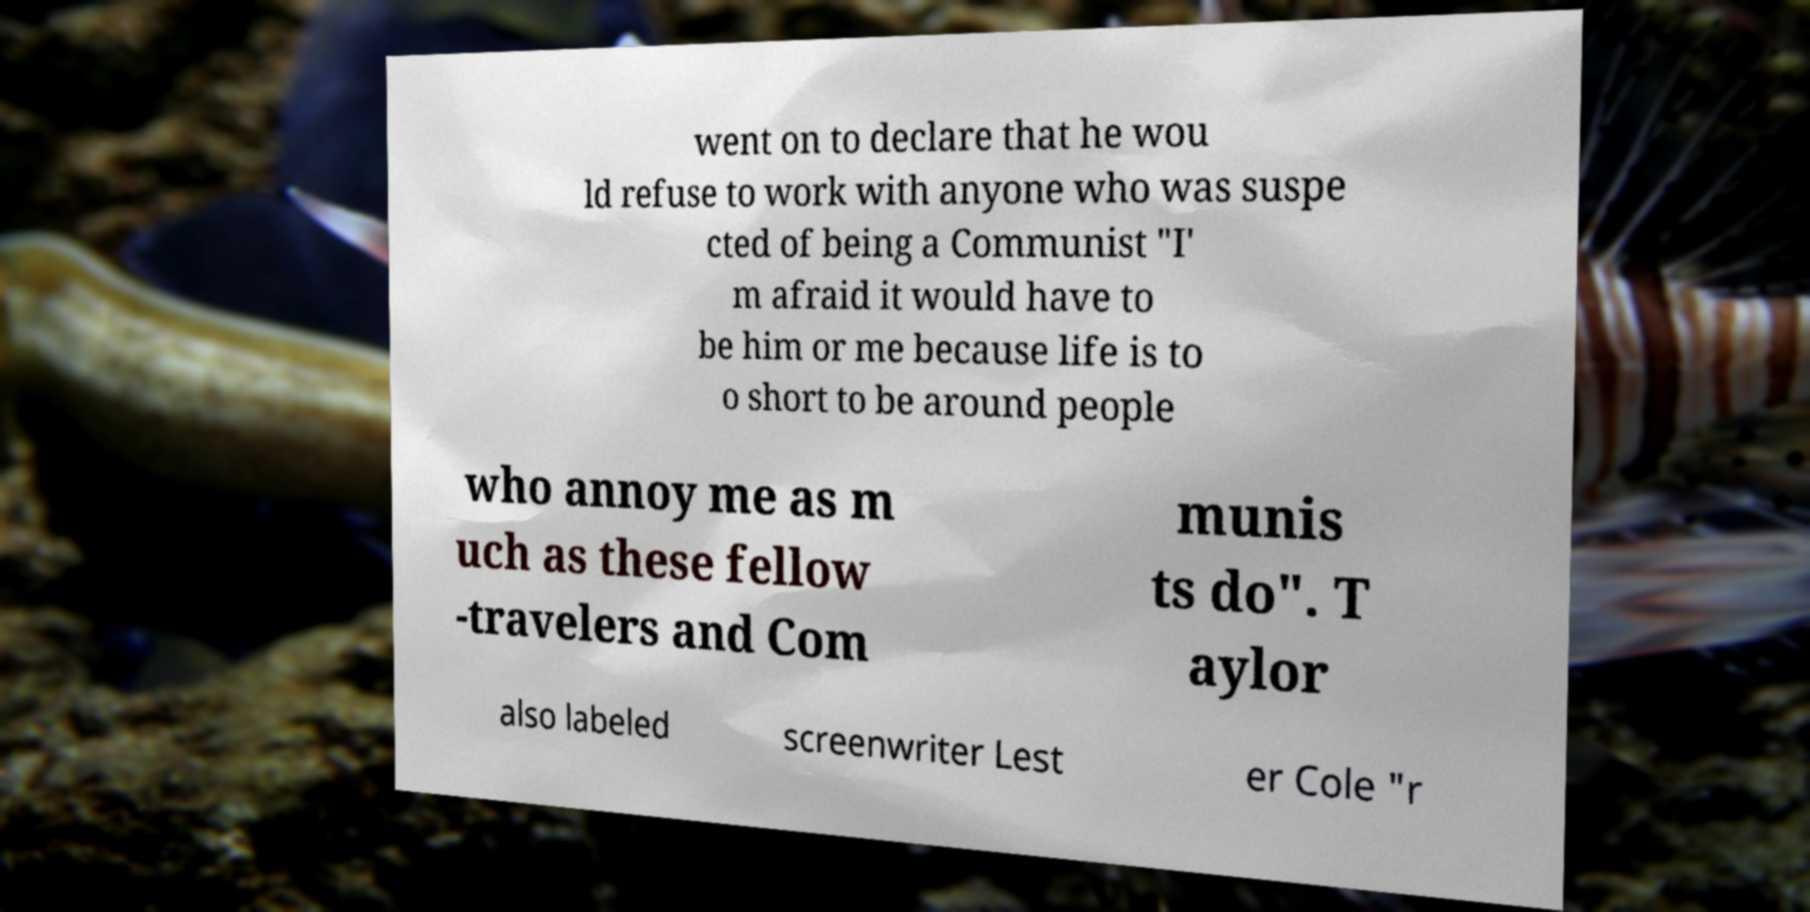There's text embedded in this image that I need extracted. Can you transcribe it verbatim? went on to declare that he wou ld refuse to work with anyone who was suspe cted of being a Communist "I' m afraid it would have to be him or me because life is to o short to be around people who annoy me as m uch as these fellow -travelers and Com munis ts do". T aylor also labeled screenwriter Lest er Cole "r 